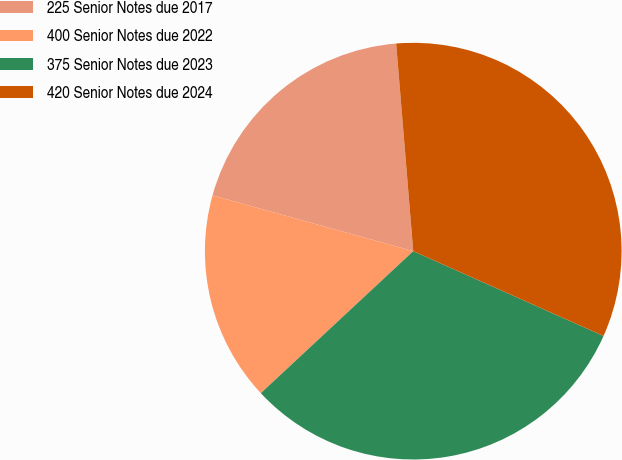Convert chart to OTSL. <chart><loc_0><loc_0><loc_500><loc_500><pie_chart><fcel>225 Senior Notes due 2017<fcel>400 Senior Notes due 2022<fcel>375 Senior Notes due 2023<fcel>420 Senior Notes due 2024<nl><fcel>19.38%<fcel>16.25%<fcel>31.39%<fcel>32.98%<nl></chart> 